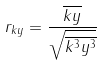<formula> <loc_0><loc_0><loc_500><loc_500>r _ { k y } = \frac { \overline { k y } } { \sqrt { \overline { k ^ { 3 } } \overline { y ^ { 3 } } } }</formula> 